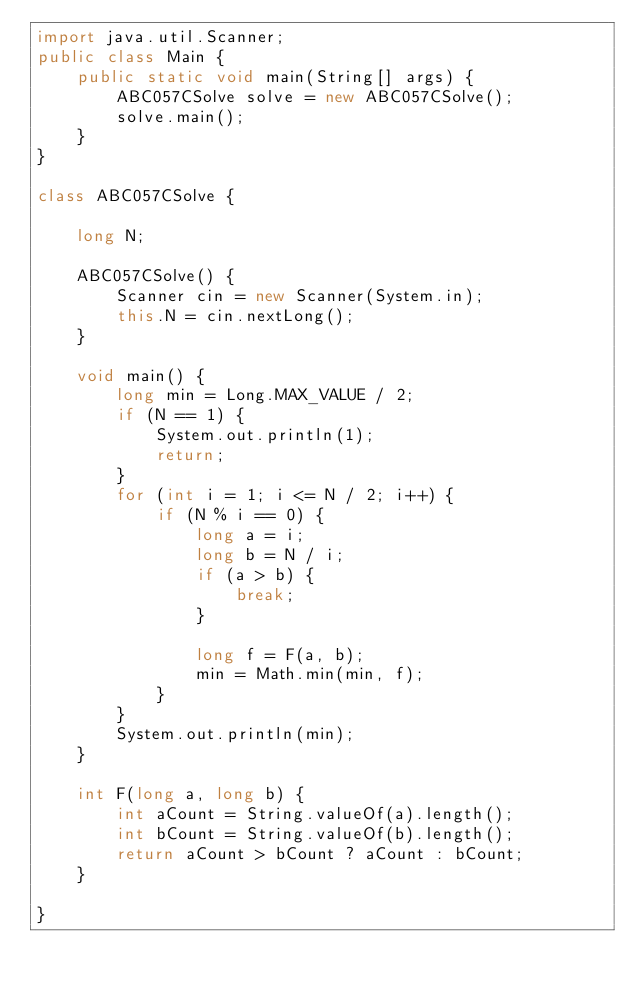<code> <loc_0><loc_0><loc_500><loc_500><_Java_>import java.util.Scanner;
public class Main {
	public static void main(String[] args) {
		ABC057CSolve solve = new ABC057CSolve();
		solve.main();
	}
}

class ABC057CSolve {
	
	long N;
	
	ABC057CSolve() {
		Scanner cin = new Scanner(System.in);
		this.N = cin.nextLong();
	}
	
	void main() {
		long min = Long.MAX_VALUE / 2;
		if (N == 1) {
			System.out.println(1);
			return;
		}
		for (int i = 1; i <= N / 2; i++) {
			if (N % i == 0) {
				long a = i;
				long b = N / i;
				if (a > b) {
					break;
				}
				
				long f = F(a, b);
				min = Math.min(min, f);
			}
		}
		System.out.println(min);
	}
	
	int F(long a, long b) {
		int aCount = String.valueOf(a).length();
		int bCount = String.valueOf(b).length();
		return aCount > bCount ? aCount : bCount;
	}

}
</code> 